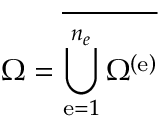Convert formula to latex. <formula><loc_0><loc_0><loc_500><loc_500>\Omega = \overline { { \bigcup _ { e = 1 } ^ { { n _ { e } } } \Omega ^ { \left ( e \right ) } } }</formula> 